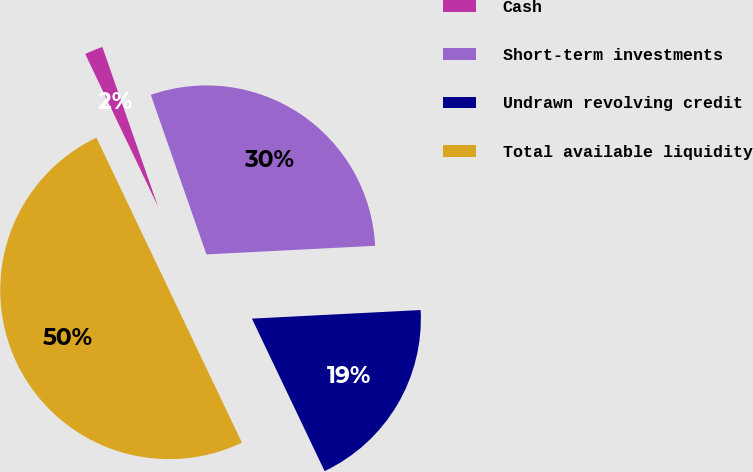Convert chart to OTSL. <chart><loc_0><loc_0><loc_500><loc_500><pie_chart><fcel>Cash<fcel>Short-term investments<fcel>Undrawn revolving credit<fcel>Total available liquidity<nl><fcel>1.75%<fcel>29.53%<fcel>18.73%<fcel>50.0%<nl></chart> 